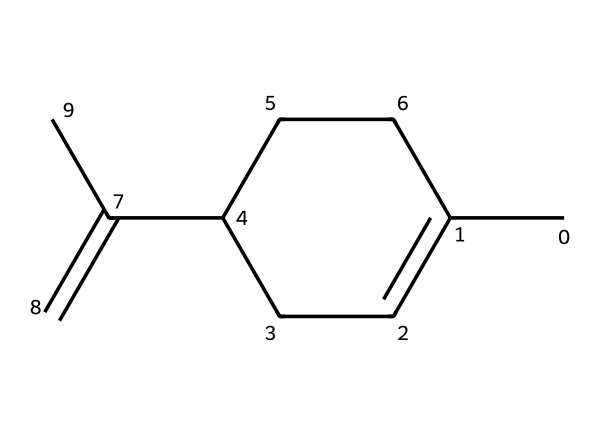How many carbon atoms are in limonene? By analyzing the SMILES representation, we can count the number of "C" letters, which represent carbon atoms. There are 10 carbon atoms in the structure.
Answer: 10 What functional group is present in limonene? The SMILES does not indicate any hydroxyl (-OH) or carbonyl (C=O) groups. Instead, it shows a double bond between two carbon atoms, indicating that limonene contains a double bond characteristic of alkenes, which is a common feature in terpenes. Thus, it lacks typical functional groups.
Answer: alkene What is the main characteristic feature of limonene? Limonene is known for its citrus aroma and flavor, characteristic of many terpenes. This can be inferred from the structure as well, since it originates from citrus fruits, indicating the presence of the alkene structure which contributes to its volatility and fragrance.
Answer: citrus aroma Is limonene a saturated or unsaturated compound? The presence of a double bond in the carbon chain (indicated by "C=C" in the SMILES) denotes that the compound is unsaturated, as saturated compounds contain only single bonds.
Answer: unsaturated How many double bonds are present in limonene? Upon inspection of the SMILES structure, there is one instance of "C=C", which indicates the presence of one double bond in limonene.
Answer: 1 What type of terpene is limonene? Limonene is classified as a monoterpene because it consists of 10 carbon atoms, aligning with the structure of monoterpenes which are derived from two isoprene units.
Answer: monoterpene What is the molecular formula of limonene? From counting the carbon (C) and hydrogen (H) atoms in the SMILES representation, we determine that there are 10 carbon atoms and 16 hydrogen atoms. Hence, the molecular formula is deduced as C10H16.
Answer: C10H16 